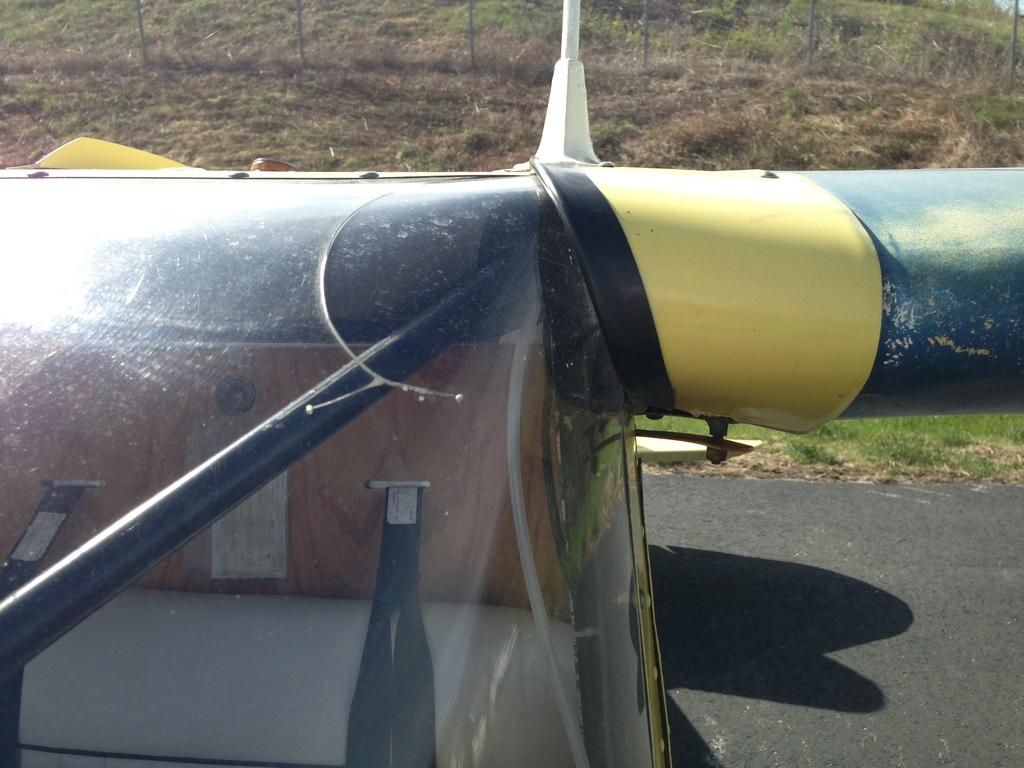What is the main subject of the image? There is a vehicle on the road in the image. What can be seen in the background of the image? The ground and grass are visible at the top of the image. What type of comfort can be found in the vehicle in the image? There is no information about the comfort level of the vehicle in the image. Can you see the mother of the driver in the image? There is no information about the driver or any passengers in the image. 